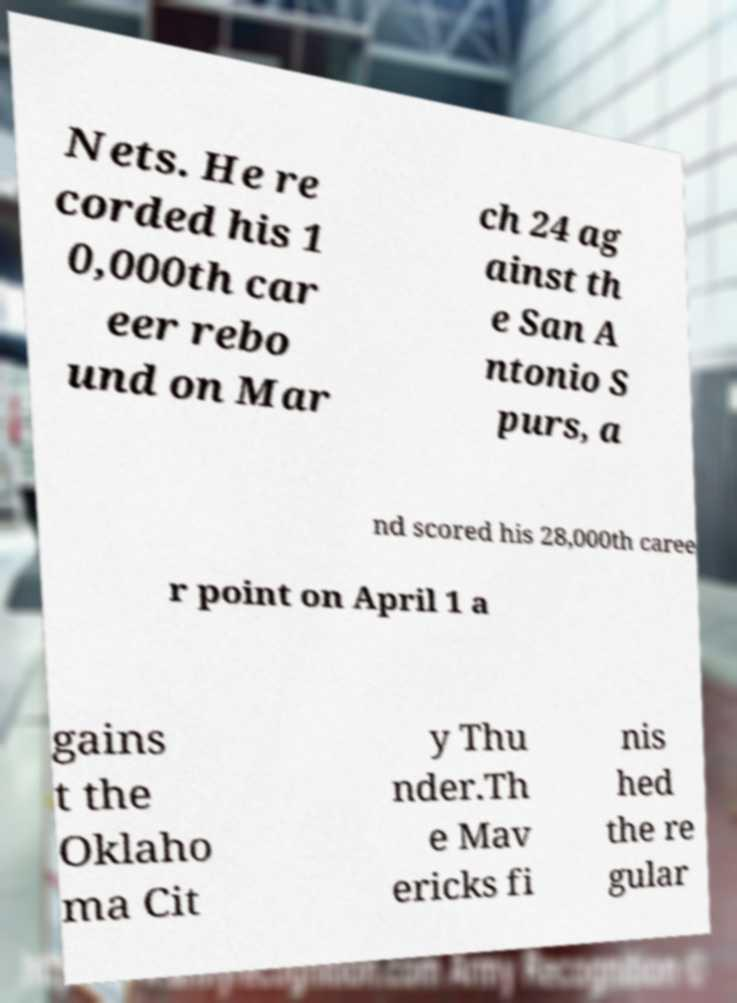What messages or text are displayed in this image? I need them in a readable, typed format. Nets. He re corded his 1 0,000th car eer rebo und on Mar ch 24 ag ainst th e San A ntonio S purs, a nd scored his 28,000th caree r point on April 1 a gains t the Oklaho ma Cit y Thu nder.Th e Mav ericks fi nis hed the re gular 